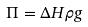<formula> <loc_0><loc_0><loc_500><loc_500>\Pi = \Delta H \rho g</formula> 